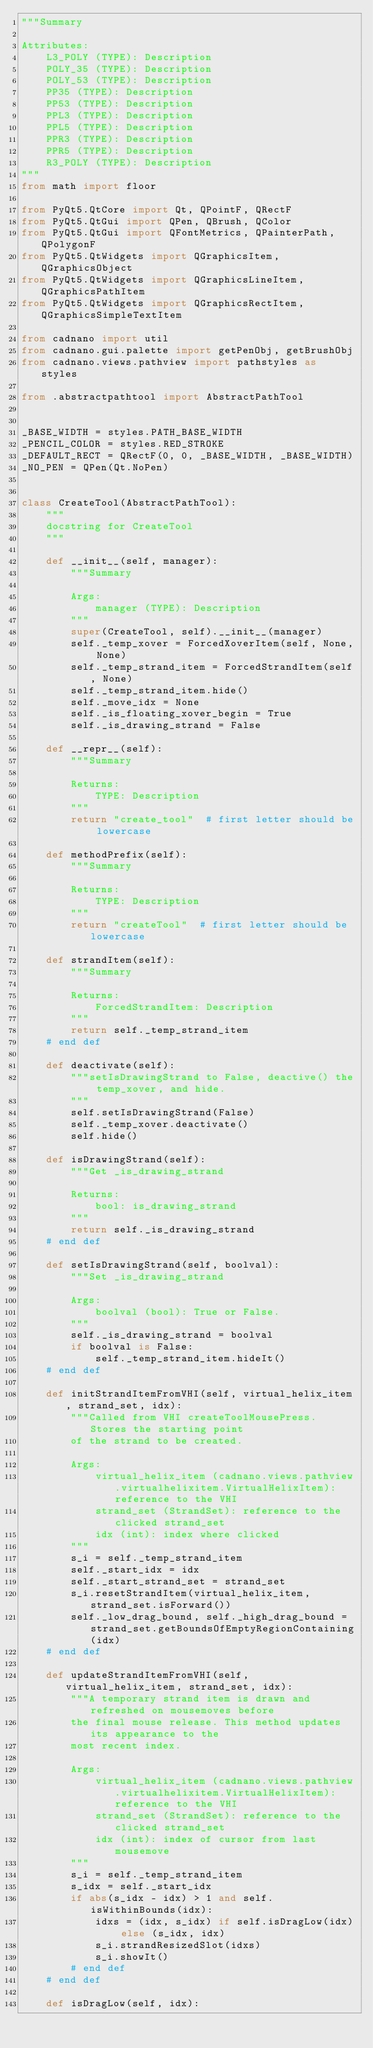Convert code to text. <code><loc_0><loc_0><loc_500><loc_500><_Python_>"""Summary

Attributes:
    L3_POLY (TYPE): Description
    POLY_35 (TYPE): Description
    POLY_53 (TYPE): Description
    PP35 (TYPE): Description
    PP53 (TYPE): Description
    PPL3 (TYPE): Description
    PPL5 (TYPE): Description
    PPR3 (TYPE): Description
    PPR5 (TYPE): Description
    R3_POLY (TYPE): Description
"""
from math import floor

from PyQt5.QtCore import Qt, QPointF, QRectF
from PyQt5.QtGui import QPen, QBrush, QColor
from PyQt5.QtGui import QFontMetrics, QPainterPath, QPolygonF
from PyQt5.QtWidgets import QGraphicsItem, QGraphicsObject
from PyQt5.QtWidgets import QGraphicsLineItem, QGraphicsPathItem
from PyQt5.QtWidgets import QGraphicsRectItem, QGraphicsSimpleTextItem

from cadnano import util
from cadnano.gui.palette import getPenObj, getBrushObj
from cadnano.views.pathview import pathstyles as styles

from .abstractpathtool import AbstractPathTool


_BASE_WIDTH = styles.PATH_BASE_WIDTH
_PENCIL_COLOR = styles.RED_STROKE
_DEFAULT_RECT = QRectF(0, 0, _BASE_WIDTH, _BASE_WIDTH)
_NO_PEN = QPen(Qt.NoPen)


class CreateTool(AbstractPathTool):
    """
    docstring for CreateTool
    """

    def __init__(self, manager):
        """Summary

        Args:
            manager (TYPE): Description
        """
        super(CreateTool, self).__init__(manager)
        self._temp_xover = ForcedXoverItem(self, None, None)
        self._temp_strand_item = ForcedStrandItem(self, None)
        self._temp_strand_item.hide()
        self._move_idx = None
        self._is_floating_xover_begin = True
        self._is_drawing_strand = False

    def __repr__(self):
        """Summary

        Returns:
            TYPE: Description
        """
        return "create_tool"  # first letter should be lowercase

    def methodPrefix(self):
        """Summary

        Returns:
            TYPE: Description
        """
        return "createTool"  # first letter should be lowercase

    def strandItem(self):
        """Summary

        Returns:
            ForcedStrandItem: Description
        """
        return self._temp_strand_item
    # end def

    def deactivate(self):
        """setIsDrawingStrand to False, deactive() the temp_xover, and hide.
        """
        self.setIsDrawingStrand(False)
        self._temp_xover.deactivate()
        self.hide()

    def isDrawingStrand(self):
        """Get _is_drawing_strand

        Returns:
            bool: is_drawing_strand
        """
        return self._is_drawing_strand
    # end def

    def setIsDrawingStrand(self, boolval):
        """Set _is_drawing_strand

        Args:
            boolval (bool): True or False.
        """
        self._is_drawing_strand = boolval
        if boolval is False:
            self._temp_strand_item.hideIt()
    # end def

    def initStrandItemFromVHI(self, virtual_helix_item, strand_set, idx):
        """Called from VHI createToolMousePress. Stores the starting point
        of the strand to be created.

        Args:
            virtual_helix_item (cadnano.views.pathview.virtualhelixitem.VirtualHelixItem): reference to the VHI
            strand_set (StrandSet): reference to the clicked strand_set
            idx (int): index where clicked
        """
        s_i = self._temp_strand_item
        self._start_idx = idx
        self._start_strand_set = strand_set
        s_i.resetStrandItem(virtual_helix_item, strand_set.isForward())
        self._low_drag_bound, self._high_drag_bound = strand_set.getBoundsOfEmptyRegionContaining(idx)
    # end def

    def updateStrandItemFromVHI(self, virtual_helix_item, strand_set, idx):
        """A temporary strand item is drawn and refreshed on mousemoves before
        the final mouse release. This method updates its appearance to the
        most recent index.

        Args:
            virtual_helix_item (cadnano.views.pathview.virtualhelixitem.VirtualHelixItem): reference to the VHI
            strand_set (StrandSet): reference to the clicked strand_set
            idx (int): index of cursor from last mousemove
        """
        s_i = self._temp_strand_item
        s_idx = self._start_idx
        if abs(s_idx - idx) > 1 and self.isWithinBounds(idx):
            idxs = (idx, s_idx) if self.isDragLow(idx) else (s_idx, idx)
            s_i.strandResizedSlot(idxs)
            s_i.showIt()
        # end def
    # end def

    def isDragLow(self, idx):</code> 